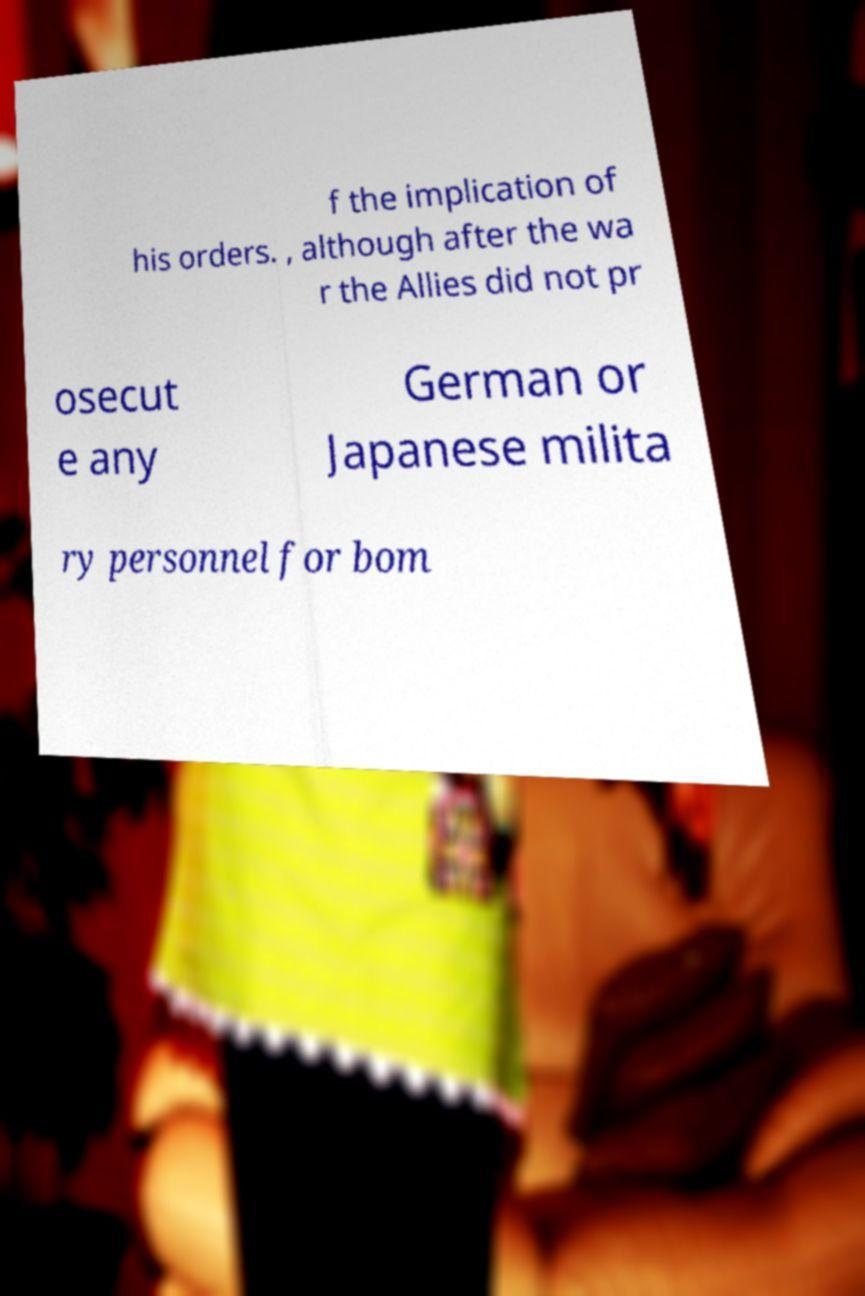Please read and relay the text visible in this image. What does it say? f the implication of his orders. , although after the wa r the Allies did not pr osecut e any German or Japanese milita ry personnel for bom 